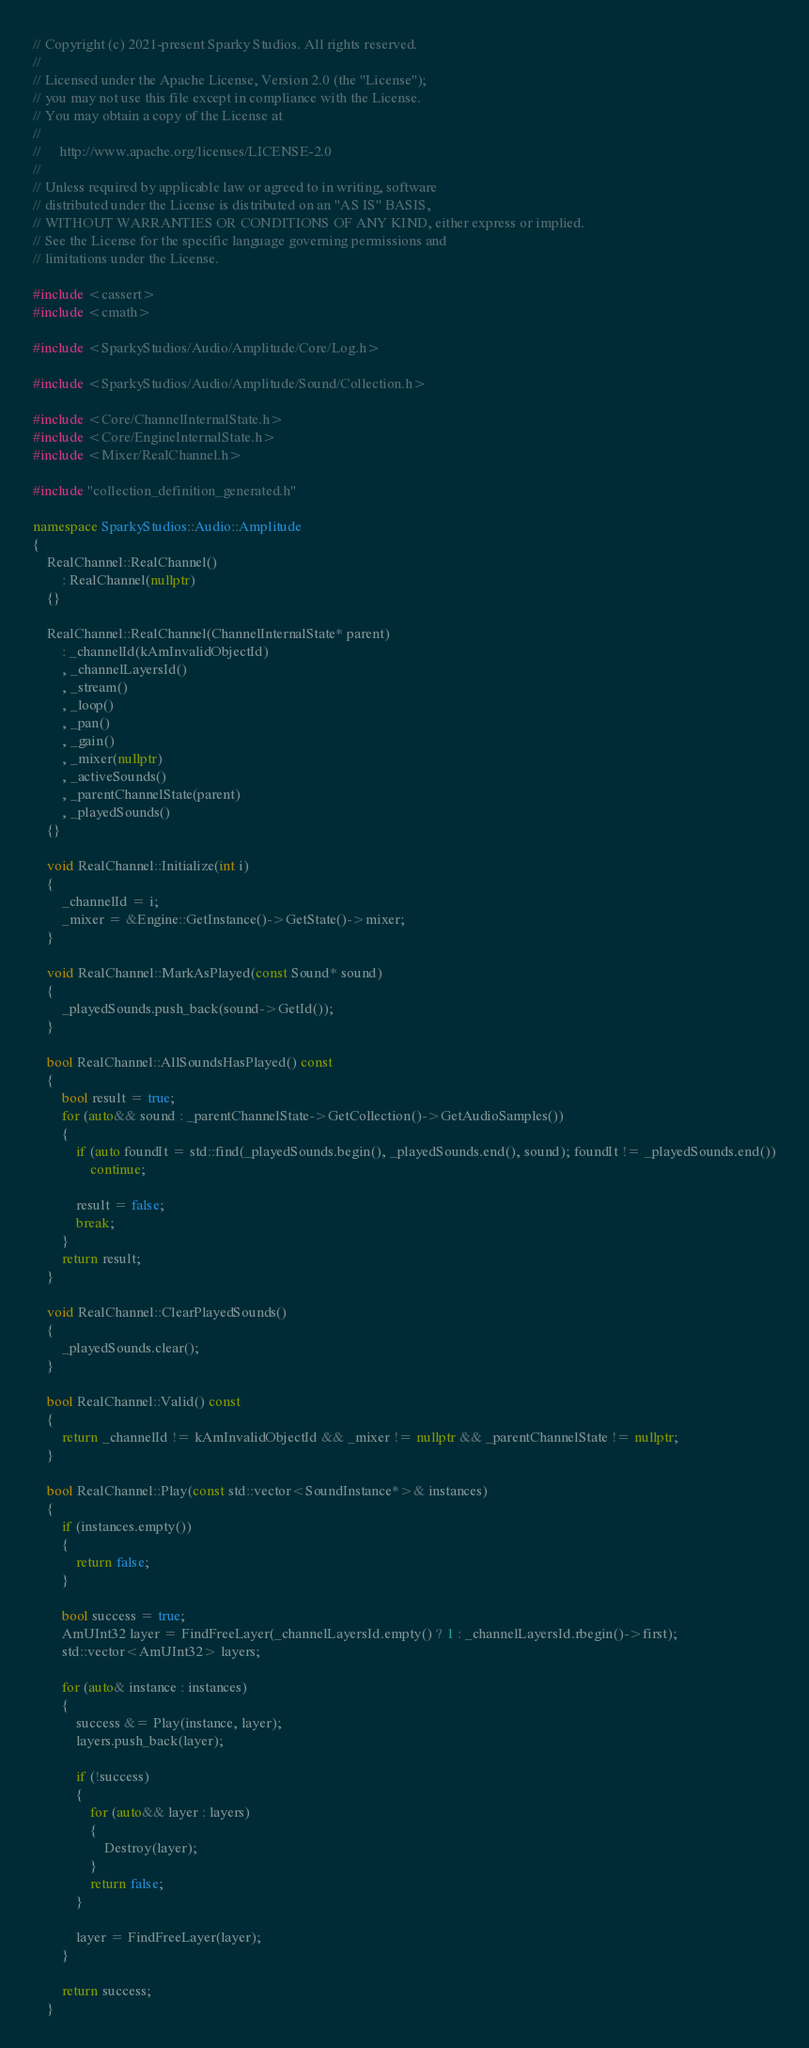Convert code to text. <code><loc_0><loc_0><loc_500><loc_500><_C++_>// Copyright (c) 2021-present Sparky Studios. All rights reserved.
//
// Licensed under the Apache License, Version 2.0 (the "License");
// you may not use this file except in compliance with the License.
// You may obtain a copy of the License at
//
//     http://www.apache.org/licenses/LICENSE-2.0
//
// Unless required by applicable law or agreed to in writing, software
// distributed under the License is distributed on an "AS IS" BASIS,
// WITHOUT WARRANTIES OR CONDITIONS OF ANY KIND, either express or implied.
// See the License for the specific language governing permissions and
// limitations under the License.

#include <cassert>
#include <cmath>

#include <SparkyStudios/Audio/Amplitude/Core/Log.h>

#include <SparkyStudios/Audio/Amplitude/Sound/Collection.h>

#include <Core/ChannelInternalState.h>
#include <Core/EngineInternalState.h>
#include <Mixer/RealChannel.h>

#include "collection_definition_generated.h"

namespace SparkyStudios::Audio::Amplitude
{
    RealChannel::RealChannel()
        : RealChannel(nullptr)
    {}

    RealChannel::RealChannel(ChannelInternalState* parent)
        : _channelId(kAmInvalidObjectId)
        , _channelLayersId()
        , _stream()
        , _loop()
        , _pan()
        , _gain()
        , _mixer(nullptr)
        , _activeSounds()
        , _parentChannelState(parent)
        , _playedSounds()
    {}

    void RealChannel::Initialize(int i)
    {
        _channelId = i;
        _mixer = &Engine::GetInstance()->GetState()->mixer;
    }

    void RealChannel::MarkAsPlayed(const Sound* sound)
    {
        _playedSounds.push_back(sound->GetId());
    }

    bool RealChannel::AllSoundsHasPlayed() const
    {
        bool result = true;
        for (auto&& sound : _parentChannelState->GetCollection()->GetAudioSamples())
        {
            if (auto foundIt = std::find(_playedSounds.begin(), _playedSounds.end(), sound); foundIt != _playedSounds.end())
                continue;

            result = false;
            break;
        }
        return result;
    }

    void RealChannel::ClearPlayedSounds()
    {
        _playedSounds.clear();
    }

    bool RealChannel::Valid() const
    {
        return _channelId != kAmInvalidObjectId && _mixer != nullptr && _parentChannelState != nullptr;
    }

    bool RealChannel::Play(const std::vector<SoundInstance*>& instances)
    {
        if (instances.empty())
        {
            return false;
        }

        bool success = true;
        AmUInt32 layer = FindFreeLayer(_channelLayersId.empty() ? 1 : _channelLayersId.rbegin()->first);
        std::vector<AmUInt32> layers;

        for (auto& instance : instances)
        {
            success &= Play(instance, layer);
            layers.push_back(layer);

            if (!success)
            {
                for (auto&& layer : layers)
                {
                    Destroy(layer);
                }
                return false;
            }

            layer = FindFreeLayer(layer);
        }

        return success;
    }
</code> 